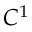<formula> <loc_0><loc_0><loc_500><loc_500>C ^ { 1 }</formula> 